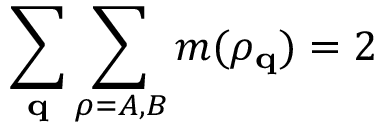<formula> <loc_0><loc_0><loc_500><loc_500>\sum _ { q } \sum _ { \rho = A , B } m ( \rho _ { q } ) = 2</formula> 